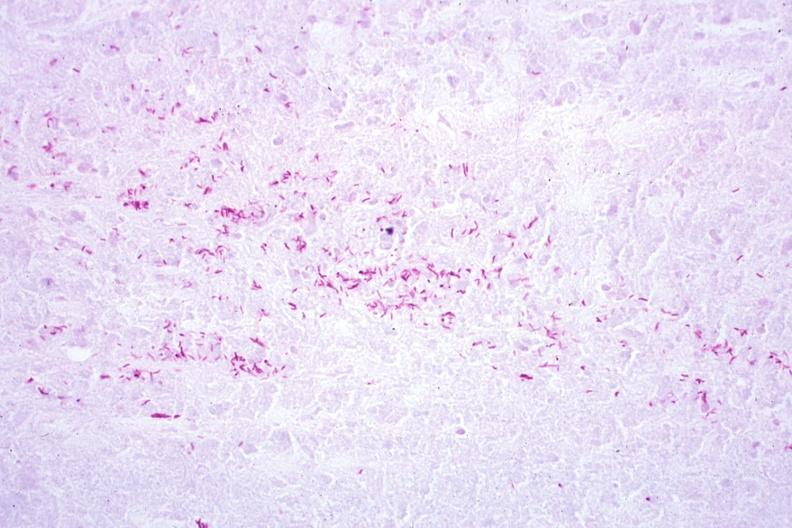what is present?
Answer the question using a single word or phrase. Lymph node 